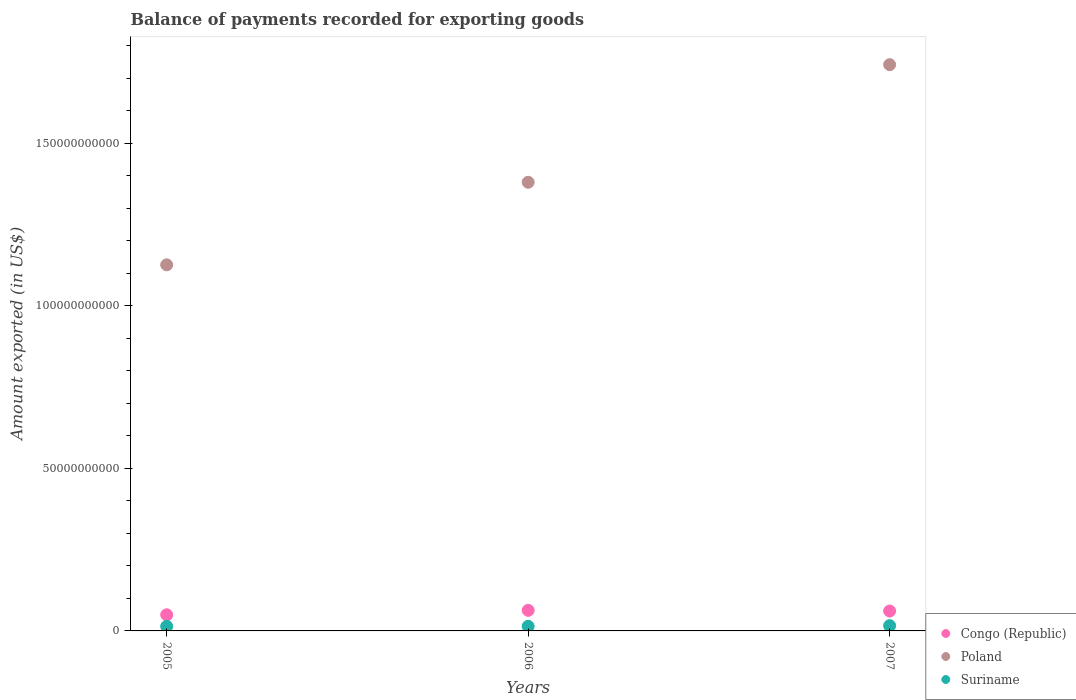What is the amount exported in Poland in 2005?
Give a very brief answer. 1.13e+11. Across all years, what is the maximum amount exported in Poland?
Offer a very short reply. 1.74e+11. Across all years, what is the minimum amount exported in Suriname?
Provide a succinct answer. 1.41e+09. In which year was the amount exported in Congo (Republic) minimum?
Offer a very short reply. 2005. What is the total amount exported in Poland in the graph?
Your answer should be very brief. 4.25e+11. What is the difference between the amount exported in Congo (Republic) in 2005 and that in 2007?
Your response must be concise. -1.16e+09. What is the difference between the amount exported in Suriname in 2005 and the amount exported in Poland in 2007?
Provide a succinct answer. -1.73e+11. What is the average amount exported in Congo (Republic) per year?
Your response must be concise. 5.81e+09. In the year 2005, what is the difference between the amount exported in Poland and amount exported in Suriname?
Your answer should be very brief. 1.11e+11. In how many years, is the amount exported in Suriname greater than 130000000000 US$?
Provide a succinct answer. 0. What is the ratio of the amount exported in Congo (Republic) in 2005 to that in 2006?
Your answer should be compact. 0.78. Is the difference between the amount exported in Poland in 2006 and 2007 greater than the difference between the amount exported in Suriname in 2006 and 2007?
Provide a short and direct response. No. What is the difference between the highest and the second highest amount exported in Poland?
Ensure brevity in your answer.  3.62e+1. What is the difference between the highest and the lowest amount exported in Poland?
Offer a very short reply. 6.16e+1. In how many years, is the amount exported in Suriname greater than the average amount exported in Suriname taken over all years?
Keep it short and to the point. 1. Is the sum of the amount exported in Poland in 2006 and 2007 greater than the maximum amount exported in Congo (Republic) across all years?
Keep it short and to the point. Yes. Does the amount exported in Suriname monotonically increase over the years?
Provide a short and direct response. No. Is the amount exported in Poland strictly greater than the amount exported in Suriname over the years?
Ensure brevity in your answer.  Yes. Is the amount exported in Poland strictly less than the amount exported in Congo (Republic) over the years?
Keep it short and to the point. No. How many dotlines are there?
Your answer should be compact. 3. How many years are there in the graph?
Offer a very short reply. 3. Does the graph contain grids?
Make the answer very short. No. How many legend labels are there?
Make the answer very short. 3. What is the title of the graph?
Ensure brevity in your answer.  Balance of payments recorded for exporting goods. What is the label or title of the X-axis?
Offer a terse response. Years. What is the label or title of the Y-axis?
Provide a succinct answer. Amount exported (in US$). What is the Amount exported (in US$) in Congo (Republic) in 2005?
Give a very brief answer. 4.97e+09. What is the Amount exported (in US$) of Poland in 2005?
Give a very brief answer. 1.13e+11. What is the Amount exported (in US$) in Suriname in 2005?
Keep it short and to the point. 1.42e+09. What is the Amount exported (in US$) of Congo (Republic) in 2006?
Ensure brevity in your answer.  6.33e+09. What is the Amount exported (in US$) in Poland in 2006?
Your response must be concise. 1.38e+11. What is the Amount exported (in US$) in Suriname in 2006?
Provide a succinct answer. 1.41e+09. What is the Amount exported (in US$) of Congo (Republic) in 2007?
Ensure brevity in your answer.  6.13e+09. What is the Amount exported (in US$) in Poland in 2007?
Your answer should be very brief. 1.74e+11. What is the Amount exported (in US$) in Suriname in 2007?
Make the answer very short. 1.61e+09. Across all years, what is the maximum Amount exported (in US$) in Congo (Republic)?
Provide a short and direct response. 6.33e+09. Across all years, what is the maximum Amount exported (in US$) in Poland?
Make the answer very short. 1.74e+11. Across all years, what is the maximum Amount exported (in US$) in Suriname?
Your response must be concise. 1.61e+09. Across all years, what is the minimum Amount exported (in US$) of Congo (Republic)?
Provide a short and direct response. 4.97e+09. Across all years, what is the minimum Amount exported (in US$) of Poland?
Your answer should be very brief. 1.13e+11. Across all years, what is the minimum Amount exported (in US$) of Suriname?
Offer a very short reply. 1.41e+09. What is the total Amount exported (in US$) of Congo (Republic) in the graph?
Offer a terse response. 1.74e+1. What is the total Amount exported (in US$) of Poland in the graph?
Give a very brief answer. 4.25e+11. What is the total Amount exported (in US$) of Suriname in the graph?
Give a very brief answer. 4.44e+09. What is the difference between the Amount exported (in US$) of Congo (Republic) in 2005 and that in 2006?
Your answer should be compact. -1.37e+09. What is the difference between the Amount exported (in US$) of Poland in 2005 and that in 2006?
Offer a very short reply. -2.54e+1. What is the difference between the Amount exported (in US$) of Suriname in 2005 and that in 2006?
Provide a succinct answer. 4.50e+06. What is the difference between the Amount exported (in US$) in Congo (Republic) in 2005 and that in 2007?
Keep it short and to the point. -1.16e+09. What is the difference between the Amount exported (in US$) in Poland in 2005 and that in 2007?
Your answer should be very brief. -6.16e+1. What is the difference between the Amount exported (in US$) of Suriname in 2005 and that in 2007?
Your answer should be compact. -1.97e+08. What is the difference between the Amount exported (in US$) in Congo (Republic) in 2006 and that in 2007?
Provide a short and direct response. 2.04e+08. What is the difference between the Amount exported (in US$) of Poland in 2006 and that in 2007?
Offer a terse response. -3.62e+1. What is the difference between the Amount exported (in US$) in Suriname in 2006 and that in 2007?
Offer a terse response. -2.01e+08. What is the difference between the Amount exported (in US$) in Congo (Republic) in 2005 and the Amount exported (in US$) in Poland in 2006?
Make the answer very short. -1.33e+11. What is the difference between the Amount exported (in US$) in Congo (Republic) in 2005 and the Amount exported (in US$) in Suriname in 2006?
Make the answer very short. 3.55e+09. What is the difference between the Amount exported (in US$) in Poland in 2005 and the Amount exported (in US$) in Suriname in 2006?
Provide a short and direct response. 1.11e+11. What is the difference between the Amount exported (in US$) of Congo (Republic) in 2005 and the Amount exported (in US$) of Poland in 2007?
Provide a short and direct response. -1.69e+11. What is the difference between the Amount exported (in US$) of Congo (Republic) in 2005 and the Amount exported (in US$) of Suriname in 2007?
Provide a short and direct response. 3.35e+09. What is the difference between the Amount exported (in US$) in Poland in 2005 and the Amount exported (in US$) in Suriname in 2007?
Give a very brief answer. 1.11e+11. What is the difference between the Amount exported (in US$) of Congo (Republic) in 2006 and the Amount exported (in US$) of Poland in 2007?
Ensure brevity in your answer.  -1.68e+11. What is the difference between the Amount exported (in US$) of Congo (Republic) in 2006 and the Amount exported (in US$) of Suriname in 2007?
Keep it short and to the point. 4.72e+09. What is the difference between the Amount exported (in US$) in Poland in 2006 and the Amount exported (in US$) in Suriname in 2007?
Offer a terse response. 1.36e+11. What is the average Amount exported (in US$) in Congo (Republic) per year?
Offer a very short reply. 5.81e+09. What is the average Amount exported (in US$) in Poland per year?
Offer a terse response. 1.42e+11. What is the average Amount exported (in US$) in Suriname per year?
Give a very brief answer. 1.48e+09. In the year 2005, what is the difference between the Amount exported (in US$) of Congo (Republic) and Amount exported (in US$) of Poland?
Provide a short and direct response. -1.08e+11. In the year 2005, what is the difference between the Amount exported (in US$) in Congo (Republic) and Amount exported (in US$) in Suriname?
Offer a terse response. 3.55e+09. In the year 2005, what is the difference between the Amount exported (in US$) in Poland and Amount exported (in US$) in Suriname?
Make the answer very short. 1.11e+11. In the year 2006, what is the difference between the Amount exported (in US$) of Congo (Republic) and Amount exported (in US$) of Poland?
Your answer should be very brief. -1.32e+11. In the year 2006, what is the difference between the Amount exported (in US$) of Congo (Republic) and Amount exported (in US$) of Suriname?
Offer a terse response. 4.92e+09. In the year 2006, what is the difference between the Amount exported (in US$) in Poland and Amount exported (in US$) in Suriname?
Ensure brevity in your answer.  1.37e+11. In the year 2007, what is the difference between the Amount exported (in US$) of Congo (Republic) and Amount exported (in US$) of Poland?
Provide a short and direct response. -1.68e+11. In the year 2007, what is the difference between the Amount exported (in US$) in Congo (Republic) and Amount exported (in US$) in Suriname?
Make the answer very short. 4.52e+09. In the year 2007, what is the difference between the Amount exported (in US$) in Poland and Amount exported (in US$) in Suriname?
Your response must be concise. 1.73e+11. What is the ratio of the Amount exported (in US$) of Congo (Republic) in 2005 to that in 2006?
Provide a succinct answer. 0.78. What is the ratio of the Amount exported (in US$) of Poland in 2005 to that in 2006?
Your response must be concise. 0.82. What is the ratio of the Amount exported (in US$) in Suriname in 2005 to that in 2006?
Give a very brief answer. 1. What is the ratio of the Amount exported (in US$) in Congo (Republic) in 2005 to that in 2007?
Give a very brief answer. 0.81. What is the ratio of the Amount exported (in US$) of Poland in 2005 to that in 2007?
Ensure brevity in your answer.  0.65. What is the ratio of the Amount exported (in US$) of Suriname in 2005 to that in 2007?
Make the answer very short. 0.88. What is the ratio of the Amount exported (in US$) of Congo (Republic) in 2006 to that in 2007?
Your answer should be compact. 1.03. What is the ratio of the Amount exported (in US$) of Poland in 2006 to that in 2007?
Your answer should be compact. 0.79. What is the ratio of the Amount exported (in US$) of Suriname in 2006 to that in 2007?
Offer a very short reply. 0.88. What is the difference between the highest and the second highest Amount exported (in US$) of Congo (Republic)?
Make the answer very short. 2.04e+08. What is the difference between the highest and the second highest Amount exported (in US$) in Poland?
Give a very brief answer. 3.62e+1. What is the difference between the highest and the second highest Amount exported (in US$) in Suriname?
Provide a succinct answer. 1.97e+08. What is the difference between the highest and the lowest Amount exported (in US$) in Congo (Republic)?
Make the answer very short. 1.37e+09. What is the difference between the highest and the lowest Amount exported (in US$) in Poland?
Ensure brevity in your answer.  6.16e+1. What is the difference between the highest and the lowest Amount exported (in US$) of Suriname?
Your response must be concise. 2.01e+08. 